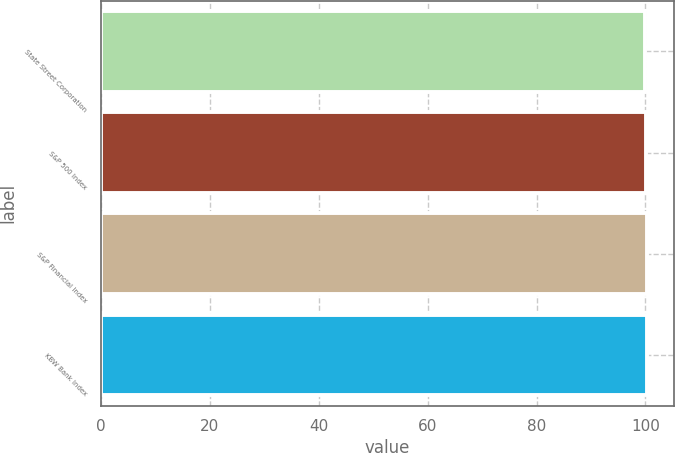Convert chart to OTSL. <chart><loc_0><loc_0><loc_500><loc_500><bar_chart><fcel>State Street Corporation<fcel>S&P 500 Index<fcel>S&P Financial Index<fcel>KBW Bank Index<nl><fcel>100<fcel>100.1<fcel>100.2<fcel>100.3<nl></chart> 